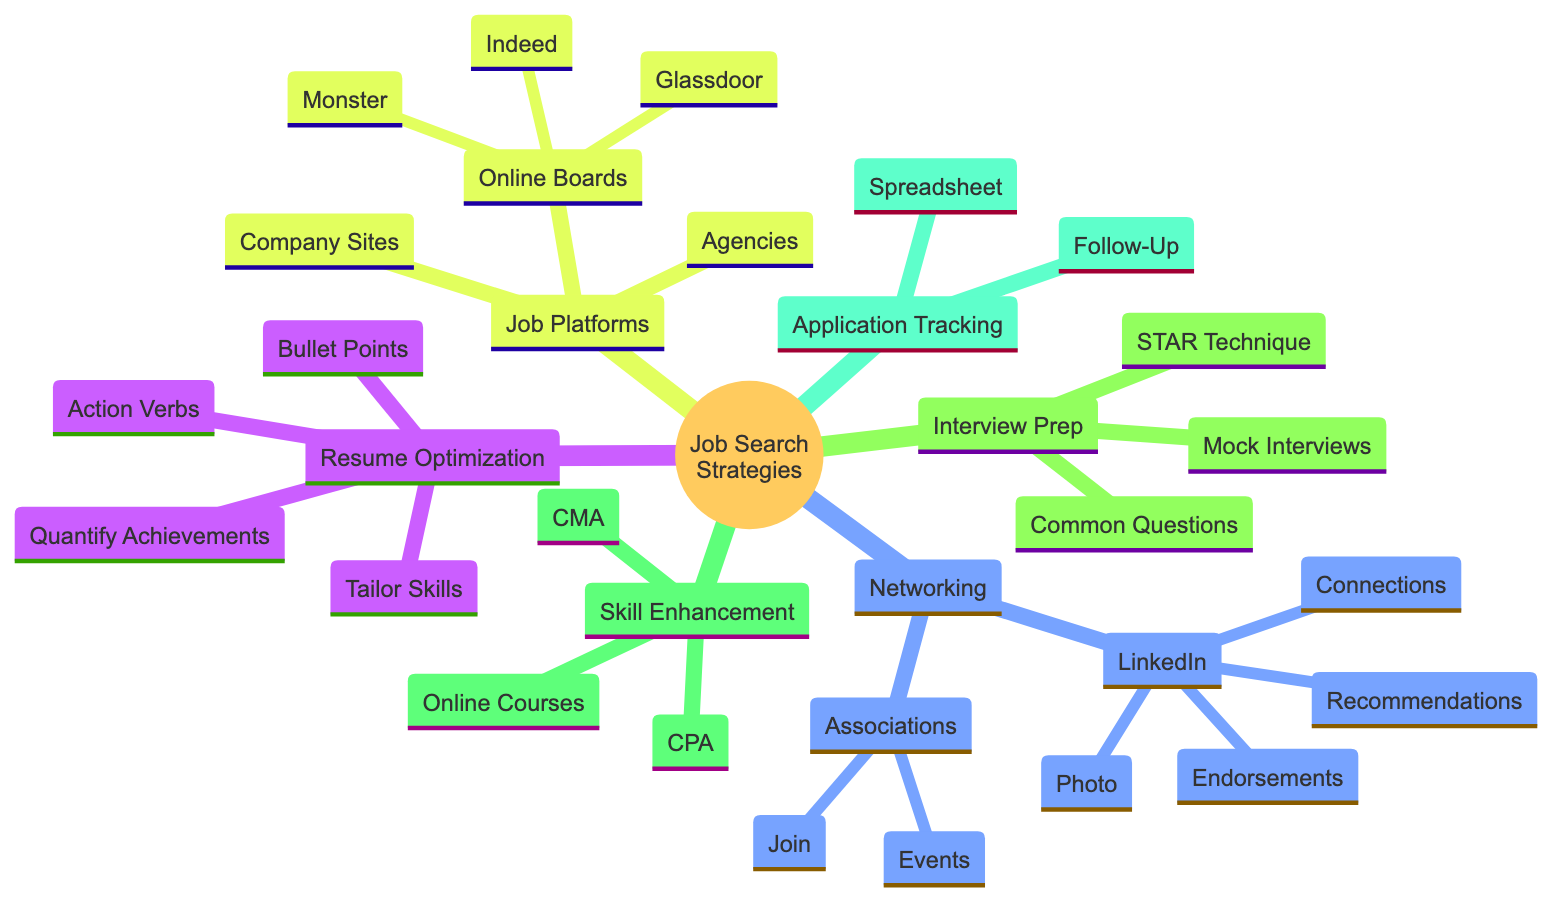What are the strategies included in the diagram? The diagram lists several strategies: Resume Optimization, Networking, Job Search Platforms, Interview Preparation, Skill Enhancement, and Application Tracking. These are the primary categories directly branching from the main topic.
Answer: Resume Optimization, Networking, Job Search Platforms, Interview Preparation, Skill Enhancement, Application Tracking How many nodes are under Networking? Under Networking, there are two main nodes: LinkedIn and Professional Associations. Each of these has sub-nodes (four for LinkedIn and two for Professional Associations), but the question asks for the top-level nodes under Networking.
Answer: 2 What is the purpose of using bullet points in resume optimization? Bullet points are used for clarity, helping to organize information succinctly and making it easier for recruiters to read and understand the qualifications and achievements presented.
Answer: Use bullet points for clarity What are the job platforms mentioned in the diagram? The diagram specifies Online Job Boards, Company Websites, and Recruitment Agencies as the categories of job platforms. Each category contains specific examples or actions to take within them.
Answer: Online Job Boards, Company Websites, Recruitment Agencies What certifications are highlighted in the Skill Enhancement section? The Skill Enhancement section mentions two specific certifications: CPA and CMA. These are professional credentials that can enhance an accountant's employability and qualifications in the field.
Answer: CPA, CMA How can one track job applications according to the diagram? The diagram suggests using a spreadsheet to track applications and highlights the importance of sending follow-up emails post-interview to maintain communication with potential employers.
Answer: Use a spreadsheet to track applications and send follow-up emails What type of technique should be used for interview responses? The diagram recommends using the STAR Technique, which stands for Situation, Task, Action, and Result. This structured approach helps in delivering clear and concise responses during interviews.
Answer: Use STAR (Situation, Task, Action, Result) technique What can you do on LinkedIn according to the diagram? The diagram outlines several actions for LinkedIn, including using a professional photo, getting endorsements for key skills, connecting with industry professionals, and requesting recommendations from colleagues.
Answer: Use a professional photo, get endorsed for key skills, connect with industry professionals, request recommendations 